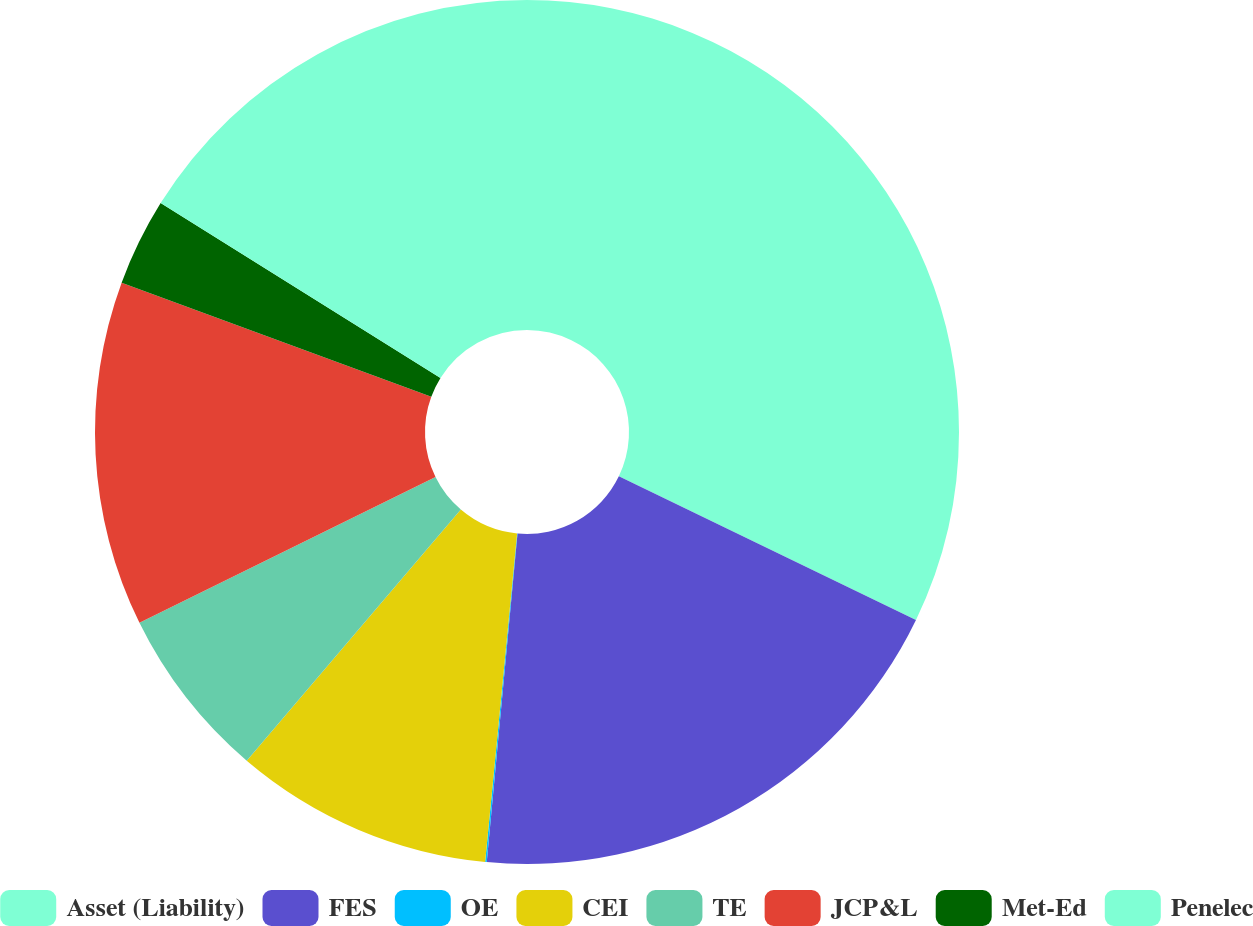Convert chart. <chart><loc_0><loc_0><loc_500><loc_500><pie_chart><fcel>Asset (Liability)<fcel>FES<fcel>OE<fcel>CEI<fcel>TE<fcel>JCP&L<fcel>Met-Ed<fcel>Penelec<nl><fcel>32.16%<fcel>19.32%<fcel>0.06%<fcel>9.69%<fcel>6.48%<fcel>12.9%<fcel>3.27%<fcel>16.11%<nl></chart> 